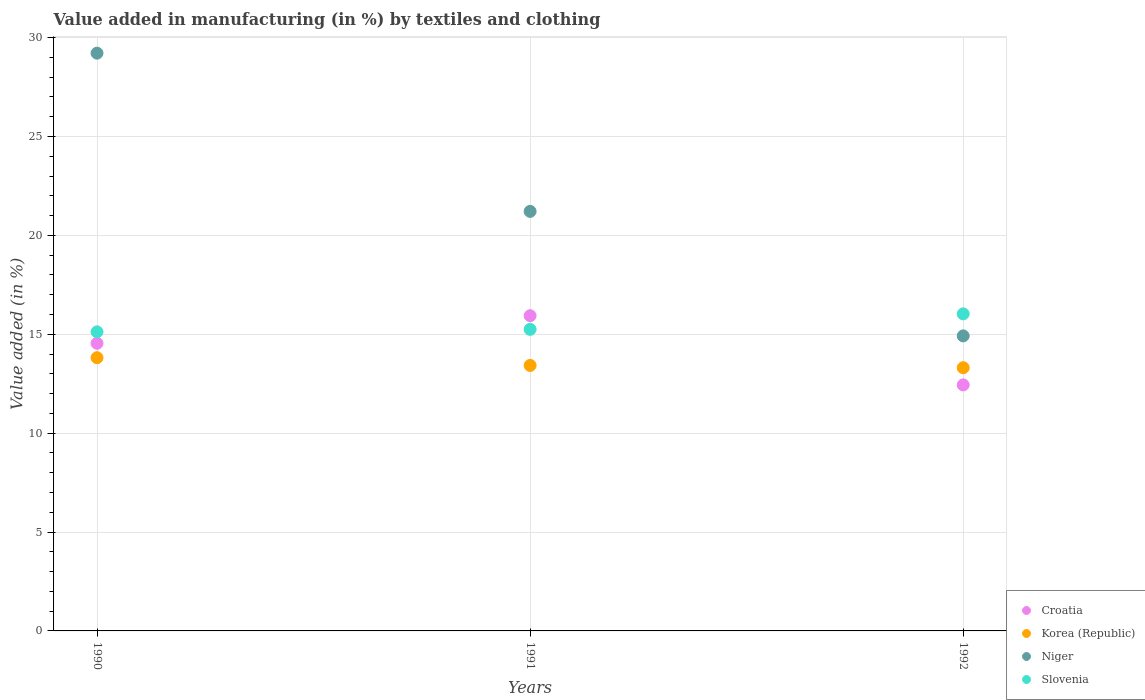How many different coloured dotlines are there?
Provide a short and direct response. 4. What is the percentage of value added in manufacturing by textiles and clothing in Slovenia in 1991?
Offer a very short reply. 15.25. Across all years, what is the maximum percentage of value added in manufacturing by textiles and clothing in Croatia?
Offer a terse response. 15.94. Across all years, what is the minimum percentage of value added in manufacturing by textiles and clothing in Slovenia?
Give a very brief answer. 15.12. What is the total percentage of value added in manufacturing by textiles and clothing in Niger in the graph?
Make the answer very short. 65.35. What is the difference between the percentage of value added in manufacturing by textiles and clothing in Slovenia in 1990 and that in 1991?
Your response must be concise. -0.13. What is the difference between the percentage of value added in manufacturing by textiles and clothing in Niger in 1992 and the percentage of value added in manufacturing by textiles and clothing in Korea (Republic) in 1990?
Provide a succinct answer. 1.1. What is the average percentage of value added in manufacturing by textiles and clothing in Croatia per year?
Make the answer very short. 14.31. In the year 1990, what is the difference between the percentage of value added in manufacturing by textiles and clothing in Korea (Republic) and percentage of value added in manufacturing by textiles and clothing in Slovenia?
Your answer should be compact. -1.31. In how many years, is the percentage of value added in manufacturing by textiles and clothing in Korea (Republic) greater than 13 %?
Make the answer very short. 3. What is the ratio of the percentage of value added in manufacturing by textiles and clothing in Slovenia in 1990 to that in 1992?
Your answer should be compact. 0.94. Is the percentage of value added in manufacturing by textiles and clothing in Slovenia in 1990 less than that in 1991?
Your response must be concise. Yes. Is the difference between the percentage of value added in manufacturing by textiles and clothing in Korea (Republic) in 1991 and 1992 greater than the difference between the percentage of value added in manufacturing by textiles and clothing in Slovenia in 1991 and 1992?
Ensure brevity in your answer.  Yes. What is the difference between the highest and the second highest percentage of value added in manufacturing by textiles and clothing in Niger?
Keep it short and to the point. 8. What is the difference between the highest and the lowest percentage of value added in manufacturing by textiles and clothing in Slovenia?
Give a very brief answer. 0.91. In how many years, is the percentage of value added in manufacturing by textiles and clothing in Korea (Republic) greater than the average percentage of value added in manufacturing by textiles and clothing in Korea (Republic) taken over all years?
Provide a succinct answer. 1. Is the sum of the percentage of value added in manufacturing by textiles and clothing in Slovenia in 1991 and 1992 greater than the maximum percentage of value added in manufacturing by textiles and clothing in Korea (Republic) across all years?
Provide a short and direct response. Yes. Is it the case that in every year, the sum of the percentage of value added in manufacturing by textiles and clothing in Slovenia and percentage of value added in manufacturing by textiles and clothing in Korea (Republic)  is greater than the sum of percentage of value added in manufacturing by textiles and clothing in Croatia and percentage of value added in manufacturing by textiles and clothing in Niger?
Provide a succinct answer. No. Is it the case that in every year, the sum of the percentage of value added in manufacturing by textiles and clothing in Slovenia and percentage of value added in manufacturing by textiles and clothing in Niger  is greater than the percentage of value added in manufacturing by textiles and clothing in Korea (Republic)?
Your response must be concise. Yes. Is the percentage of value added in manufacturing by textiles and clothing in Niger strictly less than the percentage of value added in manufacturing by textiles and clothing in Korea (Republic) over the years?
Offer a terse response. No. How many years are there in the graph?
Make the answer very short. 3. How many legend labels are there?
Keep it short and to the point. 4. What is the title of the graph?
Provide a short and direct response. Value added in manufacturing (in %) by textiles and clothing. What is the label or title of the Y-axis?
Your answer should be very brief. Value added (in %). What is the Value added (in %) in Croatia in 1990?
Provide a short and direct response. 14.54. What is the Value added (in %) in Korea (Republic) in 1990?
Keep it short and to the point. 13.82. What is the Value added (in %) of Niger in 1990?
Offer a terse response. 29.21. What is the Value added (in %) of Slovenia in 1990?
Make the answer very short. 15.12. What is the Value added (in %) of Croatia in 1991?
Give a very brief answer. 15.94. What is the Value added (in %) in Korea (Republic) in 1991?
Your response must be concise. 13.42. What is the Value added (in %) in Niger in 1991?
Your response must be concise. 21.21. What is the Value added (in %) in Slovenia in 1991?
Provide a short and direct response. 15.25. What is the Value added (in %) in Croatia in 1992?
Offer a terse response. 12.44. What is the Value added (in %) of Korea (Republic) in 1992?
Ensure brevity in your answer.  13.31. What is the Value added (in %) in Niger in 1992?
Your answer should be very brief. 14.92. What is the Value added (in %) of Slovenia in 1992?
Give a very brief answer. 16.03. Across all years, what is the maximum Value added (in %) of Croatia?
Offer a terse response. 15.94. Across all years, what is the maximum Value added (in %) in Korea (Republic)?
Give a very brief answer. 13.82. Across all years, what is the maximum Value added (in %) of Niger?
Ensure brevity in your answer.  29.21. Across all years, what is the maximum Value added (in %) of Slovenia?
Ensure brevity in your answer.  16.03. Across all years, what is the minimum Value added (in %) of Croatia?
Provide a succinct answer. 12.44. Across all years, what is the minimum Value added (in %) in Korea (Republic)?
Keep it short and to the point. 13.31. Across all years, what is the minimum Value added (in %) of Niger?
Offer a terse response. 14.92. Across all years, what is the minimum Value added (in %) of Slovenia?
Keep it short and to the point. 15.12. What is the total Value added (in %) in Croatia in the graph?
Offer a terse response. 42.92. What is the total Value added (in %) in Korea (Republic) in the graph?
Offer a terse response. 40.55. What is the total Value added (in %) in Niger in the graph?
Make the answer very short. 65.35. What is the total Value added (in %) of Slovenia in the graph?
Give a very brief answer. 46.4. What is the difference between the Value added (in %) of Croatia in 1990 and that in 1991?
Your response must be concise. -1.39. What is the difference between the Value added (in %) in Korea (Republic) in 1990 and that in 1991?
Keep it short and to the point. 0.39. What is the difference between the Value added (in %) of Niger in 1990 and that in 1991?
Your answer should be very brief. 8. What is the difference between the Value added (in %) of Slovenia in 1990 and that in 1991?
Your answer should be very brief. -0.13. What is the difference between the Value added (in %) of Croatia in 1990 and that in 1992?
Your answer should be compact. 2.1. What is the difference between the Value added (in %) of Korea (Republic) in 1990 and that in 1992?
Your answer should be very brief. 0.51. What is the difference between the Value added (in %) of Niger in 1990 and that in 1992?
Provide a short and direct response. 14.3. What is the difference between the Value added (in %) of Slovenia in 1990 and that in 1992?
Provide a succinct answer. -0.91. What is the difference between the Value added (in %) of Croatia in 1991 and that in 1992?
Offer a very short reply. 3.5. What is the difference between the Value added (in %) in Korea (Republic) in 1991 and that in 1992?
Give a very brief answer. 0.12. What is the difference between the Value added (in %) of Niger in 1991 and that in 1992?
Your response must be concise. 6.3. What is the difference between the Value added (in %) of Slovenia in 1991 and that in 1992?
Offer a terse response. -0.78. What is the difference between the Value added (in %) of Croatia in 1990 and the Value added (in %) of Korea (Republic) in 1991?
Provide a succinct answer. 1.12. What is the difference between the Value added (in %) in Croatia in 1990 and the Value added (in %) in Niger in 1991?
Your answer should be compact. -6.67. What is the difference between the Value added (in %) of Croatia in 1990 and the Value added (in %) of Slovenia in 1991?
Your answer should be compact. -0.7. What is the difference between the Value added (in %) in Korea (Republic) in 1990 and the Value added (in %) in Niger in 1991?
Provide a short and direct response. -7.4. What is the difference between the Value added (in %) of Korea (Republic) in 1990 and the Value added (in %) of Slovenia in 1991?
Give a very brief answer. -1.43. What is the difference between the Value added (in %) in Niger in 1990 and the Value added (in %) in Slovenia in 1991?
Give a very brief answer. 13.97. What is the difference between the Value added (in %) in Croatia in 1990 and the Value added (in %) in Korea (Republic) in 1992?
Your answer should be very brief. 1.24. What is the difference between the Value added (in %) of Croatia in 1990 and the Value added (in %) of Niger in 1992?
Provide a succinct answer. -0.37. What is the difference between the Value added (in %) of Croatia in 1990 and the Value added (in %) of Slovenia in 1992?
Make the answer very short. -1.49. What is the difference between the Value added (in %) of Korea (Republic) in 1990 and the Value added (in %) of Niger in 1992?
Your answer should be very brief. -1.1. What is the difference between the Value added (in %) of Korea (Republic) in 1990 and the Value added (in %) of Slovenia in 1992?
Offer a very short reply. -2.22. What is the difference between the Value added (in %) in Niger in 1990 and the Value added (in %) in Slovenia in 1992?
Keep it short and to the point. 13.18. What is the difference between the Value added (in %) of Croatia in 1991 and the Value added (in %) of Korea (Republic) in 1992?
Provide a short and direct response. 2.63. What is the difference between the Value added (in %) in Croatia in 1991 and the Value added (in %) in Niger in 1992?
Offer a very short reply. 1.02. What is the difference between the Value added (in %) in Croatia in 1991 and the Value added (in %) in Slovenia in 1992?
Your response must be concise. -0.09. What is the difference between the Value added (in %) of Korea (Republic) in 1991 and the Value added (in %) of Niger in 1992?
Your answer should be very brief. -1.49. What is the difference between the Value added (in %) of Korea (Republic) in 1991 and the Value added (in %) of Slovenia in 1992?
Your response must be concise. -2.61. What is the difference between the Value added (in %) of Niger in 1991 and the Value added (in %) of Slovenia in 1992?
Offer a very short reply. 5.18. What is the average Value added (in %) in Croatia per year?
Offer a terse response. 14.31. What is the average Value added (in %) of Korea (Republic) per year?
Your response must be concise. 13.52. What is the average Value added (in %) in Niger per year?
Ensure brevity in your answer.  21.78. What is the average Value added (in %) in Slovenia per year?
Your answer should be very brief. 15.47. In the year 1990, what is the difference between the Value added (in %) in Croatia and Value added (in %) in Korea (Republic)?
Ensure brevity in your answer.  0.73. In the year 1990, what is the difference between the Value added (in %) of Croatia and Value added (in %) of Niger?
Offer a terse response. -14.67. In the year 1990, what is the difference between the Value added (in %) of Croatia and Value added (in %) of Slovenia?
Provide a succinct answer. -0.58. In the year 1990, what is the difference between the Value added (in %) of Korea (Republic) and Value added (in %) of Niger?
Your response must be concise. -15.4. In the year 1990, what is the difference between the Value added (in %) in Korea (Republic) and Value added (in %) in Slovenia?
Offer a very short reply. -1.31. In the year 1990, what is the difference between the Value added (in %) of Niger and Value added (in %) of Slovenia?
Offer a very short reply. 14.09. In the year 1991, what is the difference between the Value added (in %) in Croatia and Value added (in %) in Korea (Republic)?
Your answer should be very brief. 2.51. In the year 1991, what is the difference between the Value added (in %) of Croatia and Value added (in %) of Niger?
Provide a short and direct response. -5.28. In the year 1991, what is the difference between the Value added (in %) of Croatia and Value added (in %) of Slovenia?
Your answer should be compact. 0.69. In the year 1991, what is the difference between the Value added (in %) of Korea (Republic) and Value added (in %) of Niger?
Your answer should be compact. -7.79. In the year 1991, what is the difference between the Value added (in %) in Korea (Republic) and Value added (in %) in Slovenia?
Provide a short and direct response. -1.82. In the year 1991, what is the difference between the Value added (in %) in Niger and Value added (in %) in Slovenia?
Keep it short and to the point. 5.96. In the year 1992, what is the difference between the Value added (in %) of Croatia and Value added (in %) of Korea (Republic)?
Offer a very short reply. -0.87. In the year 1992, what is the difference between the Value added (in %) in Croatia and Value added (in %) in Niger?
Give a very brief answer. -2.48. In the year 1992, what is the difference between the Value added (in %) in Croatia and Value added (in %) in Slovenia?
Provide a succinct answer. -3.59. In the year 1992, what is the difference between the Value added (in %) of Korea (Republic) and Value added (in %) of Niger?
Make the answer very short. -1.61. In the year 1992, what is the difference between the Value added (in %) in Korea (Republic) and Value added (in %) in Slovenia?
Give a very brief answer. -2.72. In the year 1992, what is the difference between the Value added (in %) of Niger and Value added (in %) of Slovenia?
Your response must be concise. -1.11. What is the ratio of the Value added (in %) of Croatia in 1990 to that in 1991?
Ensure brevity in your answer.  0.91. What is the ratio of the Value added (in %) of Korea (Republic) in 1990 to that in 1991?
Your response must be concise. 1.03. What is the ratio of the Value added (in %) of Niger in 1990 to that in 1991?
Make the answer very short. 1.38. What is the ratio of the Value added (in %) of Croatia in 1990 to that in 1992?
Keep it short and to the point. 1.17. What is the ratio of the Value added (in %) in Korea (Republic) in 1990 to that in 1992?
Your answer should be compact. 1.04. What is the ratio of the Value added (in %) of Niger in 1990 to that in 1992?
Keep it short and to the point. 1.96. What is the ratio of the Value added (in %) in Slovenia in 1990 to that in 1992?
Your response must be concise. 0.94. What is the ratio of the Value added (in %) of Croatia in 1991 to that in 1992?
Ensure brevity in your answer.  1.28. What is the ratio of the Value added (in %) in Korea (Republic) in 1991 to that in 1992?
Your answer should be compact. 1.01. What is the ratio of the Value added (in %) of Niger in 1991 to that in 1992?
Your response must be concise. 1.42. What is the ratio of the Value added (in %) of Slovenia in 1991 to that in 1992?
Keep it short and to the point. 0.95. What is the difference between the highest and the second highest Value added (in %) in Croatia?
Give a very brief answer. 1.39. What is the difference between the highest and the second highest Value added (in %) in Korea (Republic)?
Provide a succinct answer. 0.39. What is the difference between the highest and the second highest Value added (in %) in Niger?
Make the answer very short. 8. What is the difference between the highest and the second highest Value added (in %) in Slovenia?
Provide a short and direct response. 0.78. What is the difference between the highest and the lowest Value added (in %) of Croatia?
Your answer should be compact. 3.5. What is the difference between the highest and the lowest Value added (in %) of Korea (Republic)?
Your response must be concise. 0.51. What is the difference between the highest and the lowest Value added (in %) in Niger?
Provide a short and direct response. 14.3. 